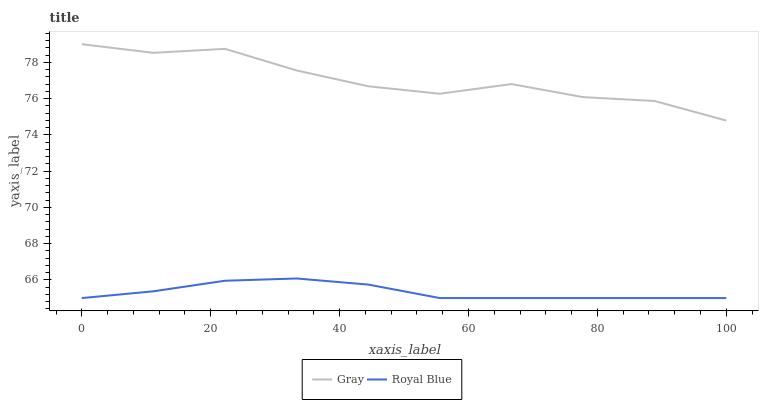Does Royal Blue have the minimum area under the curve?
Answer yes or no. Yes. Does Gray have the maximum area under the curve?
Answer yes or no. Yes. Does Royal Blue have the maximum area under the curve?
Answer yes or no. No. Is Royal Blue the smoothest?
Answer yes or no. Yes. Is Gray the roughest?
Answer yes or no. Yes. Is Royal Blue the roughest?
Answer yes or no. No. Does Royal Blue have the lowest value?
Answer yes or no. Yes. Does Gray have the highest value?
Answer yes or no. Yes. Does Royal Blue have the highest value?
Answer yes or no. No. Is Royal Blue less than Gray?
Answer yes or no. Yes. Is Gray greater than Royal Blue?
Answer yes or no. Yes. Does Royal Blue intersect Gray?
Answer yes or no. No. 